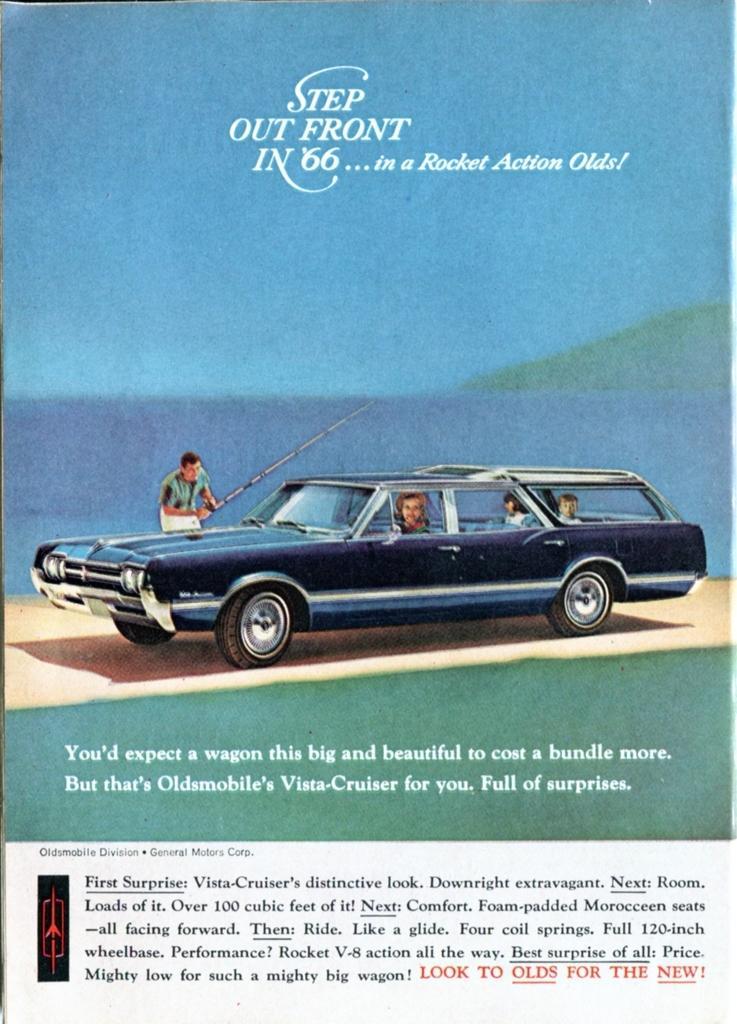In one or two sentences, can you explain what this image depicts? In this image we can see a paper. In the paper there are the pictures of sky, hills, water, person standing on the road and holding fishing rod in the hands and persons sitting in the motor vehicle. At the bottom of the paper we can see the text. 